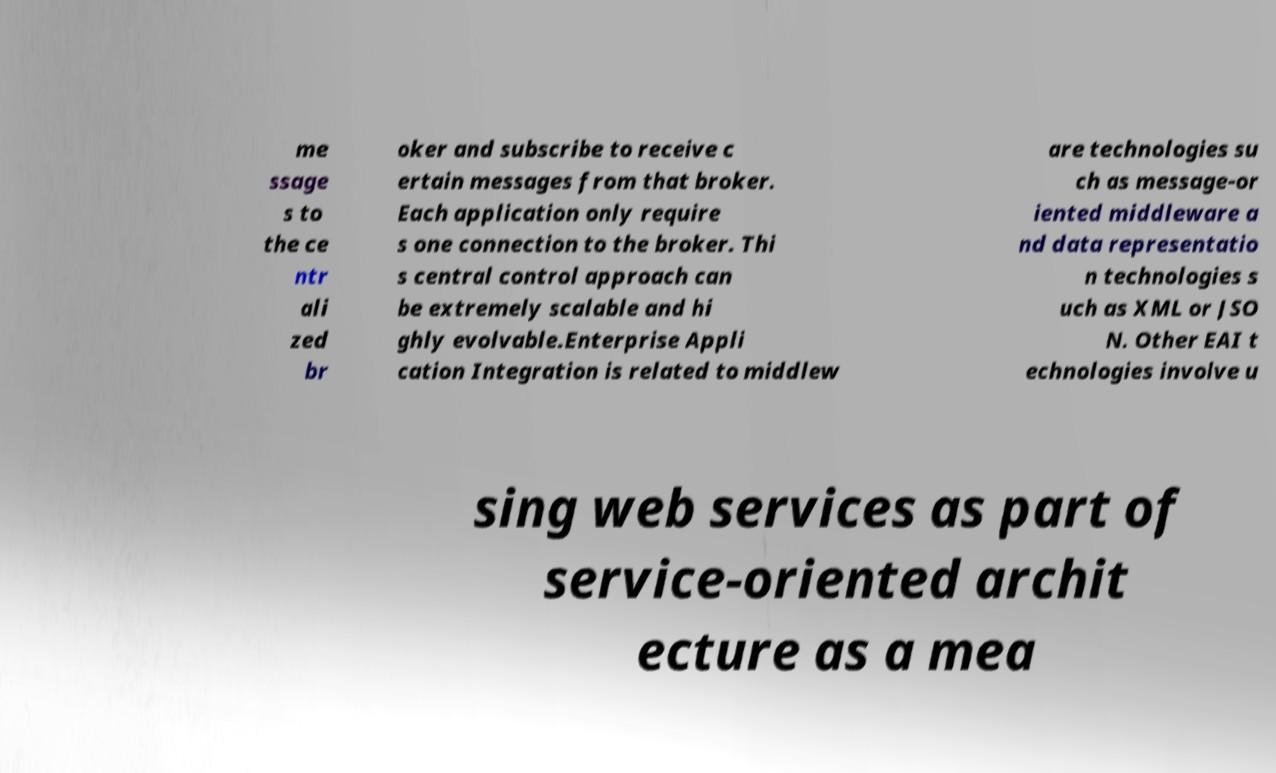Please read and relay the text visible in this image. What does it say? me ssage s to the ce ntr ali zed br oker and subscribe to receive c ertain messages from that broker. Each application only require s one connection to the broker. Thi s central control approach can be extremely scalable and hi ghly evolvable.Enterprise Appli cation Integration is related to middlew are technologies su ch as message-or iented middleware a nd data representatio n technologies s uch as XML or JSO N. Other EAI t echnologies involve u sing web services as part of service-oriented archit ecture as a mea 